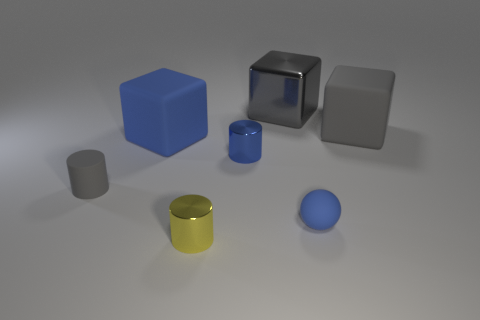Can you describe the lighting in the scene? The scene is evenly lit with soft shadows, indicating diffuse lighting, likely from an overhead source. There's no harsh lighting or strong directional shadows, which gives the objects a soft appearance. 